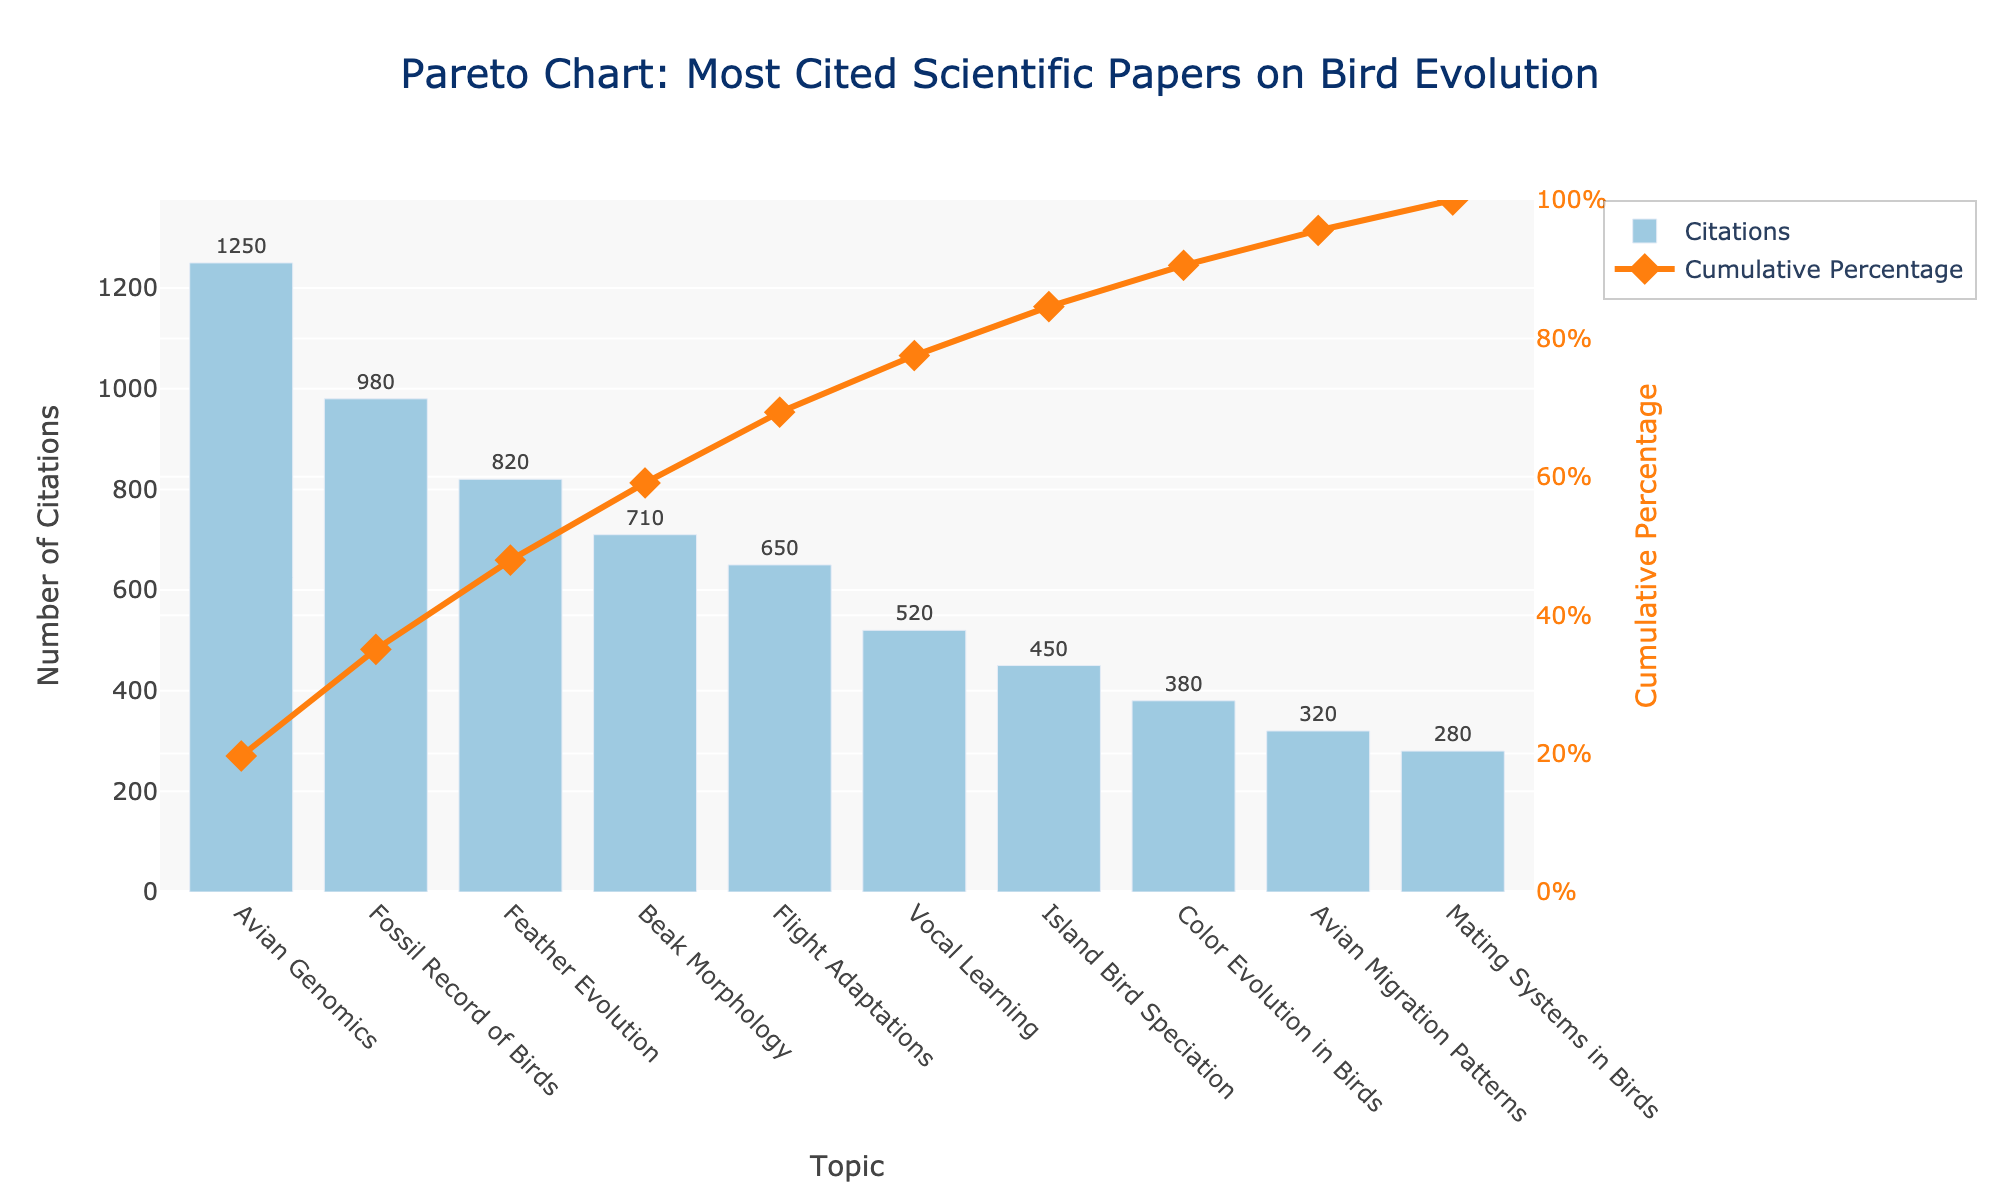What's the title of the chart? The title is usually at the top of the chart and summarizes the main subject. Here, the title text is large and centered.
Answer: Pareto Chart: Most Cited Scientific Papers on Bird Evolution How many topics are included in the chart? Count the number of unique entries on the x-axis, each representing a different topic.
Answer: 10 Which topic has the highest number of citations? Look at the tallest bar in the bar chart. The corresponding x-axis label is the topic with the highest citations.
Answer: Avian Genomics What is the cumulative percentage after the top three most cited topics? Locate the cumulative percentage points marked on the line trace for the first three topics and sum them up.
Answer: 76.5% What is the difference in the number of citations between 'Feather Evolution' and 'Mating Systems in Birds'? Subtract the number of citations for 'Mating Systems in Birds' from 'Feather Evolution'. Refer to the text on the bars for precise values.
Answer: 820 - 280 = 540 Which topic contributes to reaching the halfway point (50%) of the cumulative percentage? Look at the cumulative percentage line and identify the topic at which the cumulative percentage is closest to 50%.
Answer: Feather Evolution How does 'Color Evolution in Birds' rank in terms of citations compared to 'Beak Morphology'? Compare the positions of these topics by looking at their bars' height.
Answer: Color Evolution in Birds has fewer citations than Beak Morphology What is the cumulative percentage contribution of the bottom three topics? Identify the last three topics on the x-axis, then locate their cumulative percentages on the curve, and calculate their cumulative percentages by subtracting the cumulative percentage of the fourth last topic.
Answer: 100% - 84.5% = 15.5% Which topic marks the point where the cumulative percentage first exceeds 70%? Find the first point on the cumulative percentage line that exceeds the 70% mark and note the corresponding topic below.
Answer: Beak Morphology What is the average number of citations for the top five topics? Add up the number of citations for the top five topics and divide by five. Use the values provided on the bars.
Answer: (1250 + 980 + 820 + 710 + 650) / 5 = 882 